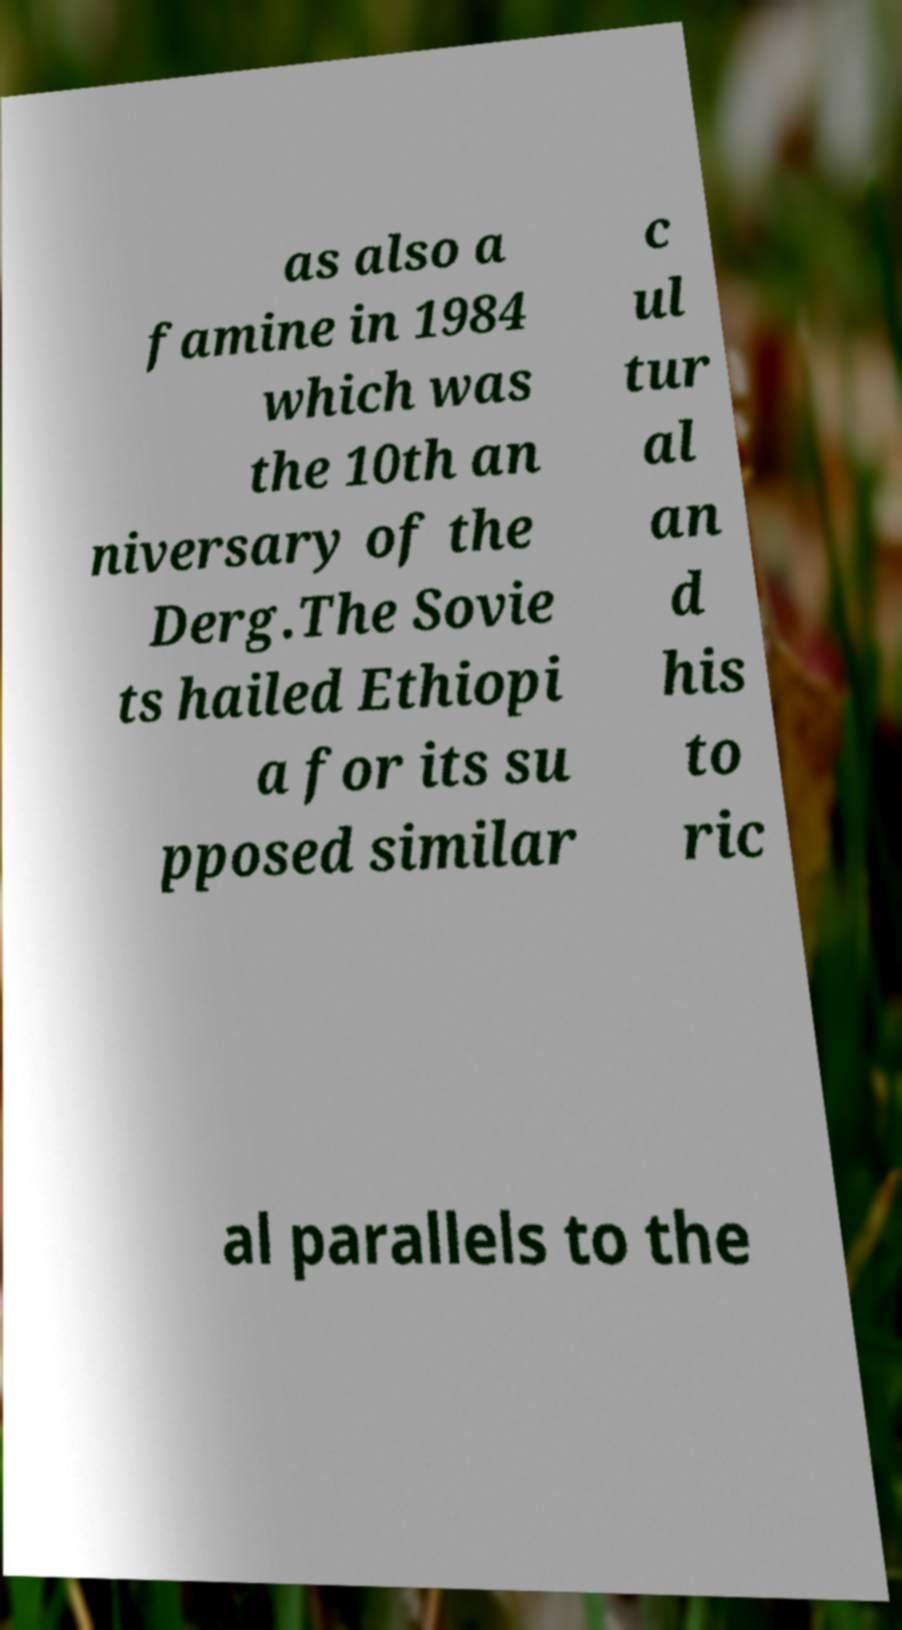Can you read and provide the text displayed in the image?This photo seems to have some interesting text. Can you extract and type it out for me? as also a famine in 1984 which was the 10th an niversary of the Derg.The Sovie ts hailed Ethiopi a for its su pposed similar c ul tur al an d his to ric al parallels to the 